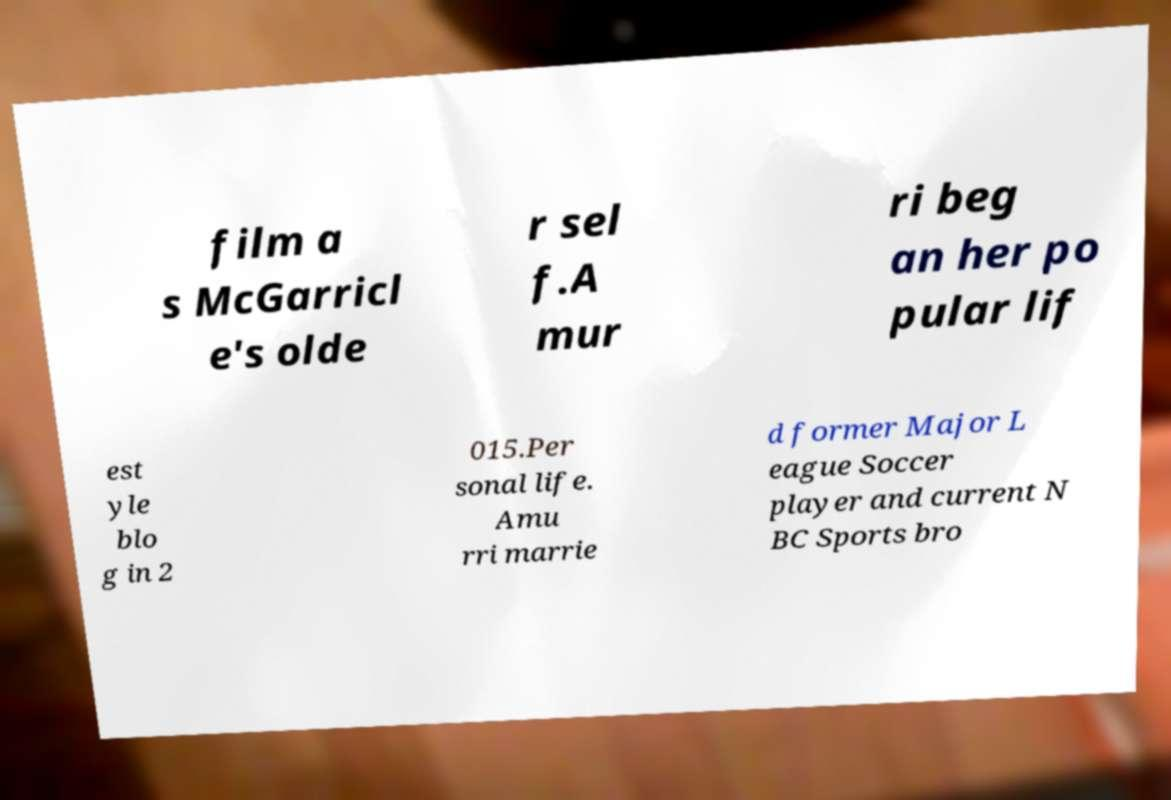Can you read and provide the text displayed in the image?This photo seems to have some interesting text. Can you extract and type it out for me? film a s McGarricl e's olde r sel f.A mur ri beg an her po pular lif est yle blo g in 2 015.Per sonal life. Amu rri marrie d former Major L eague Soccer player and current N BC Sports bro 